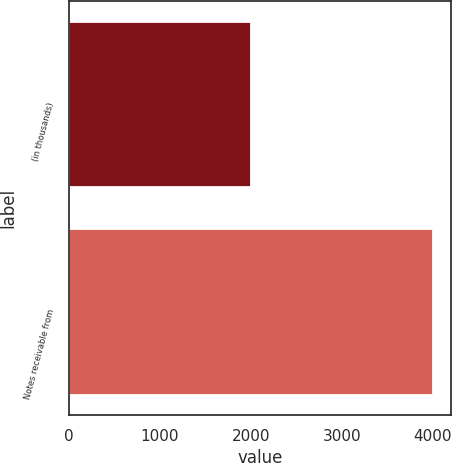<chart> <loc_0><loc_0><loc_500><loc_500><bar_chart><fcel>(in thousands)<fcel>Notes receivable from<nl><fcel>2007<fcel>4006<nl></chart> 